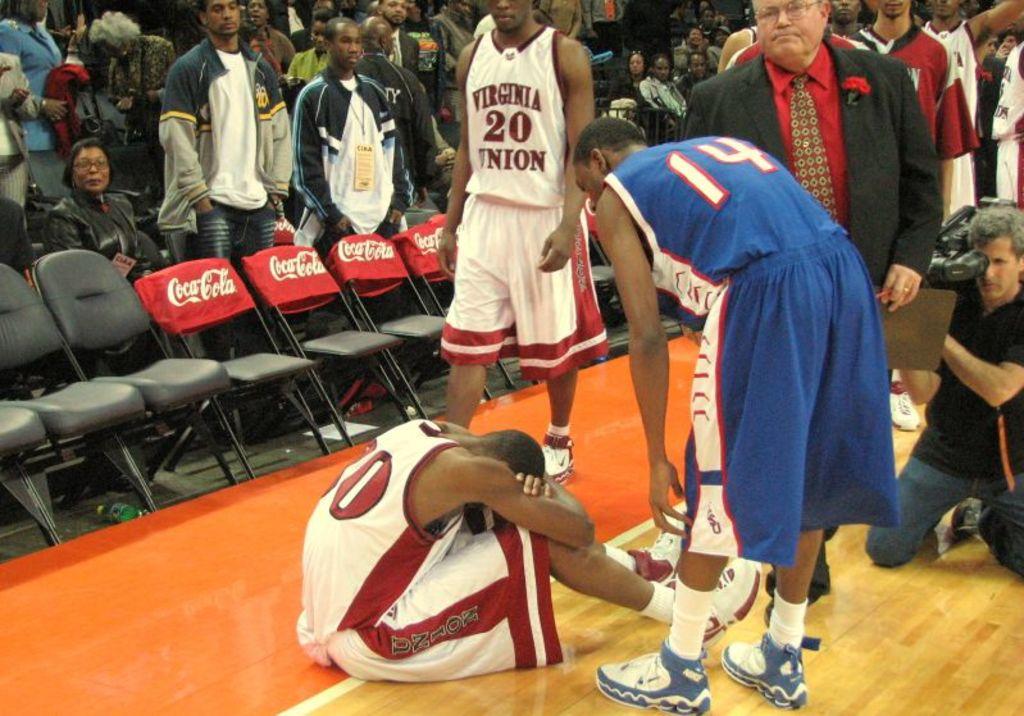What product is being advertised on the backs of the chairs?
Your answer should be compact. Coca cola. What number is on the jersey of the standing man?
Your response must be concise. 20. 